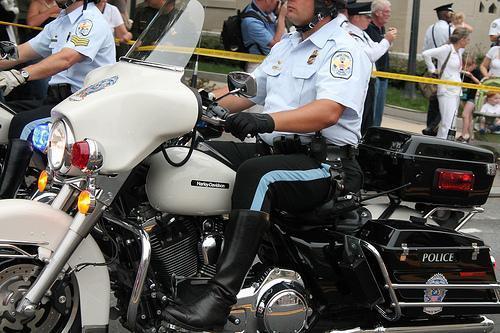How many motorcycles are on the street?
Give a very brief answer. 2. How many police officers are seen?
Give a very brief answer. 2. How many times can you see the words "harley davidson" in the picture?
Give a very brief answer. 1. 